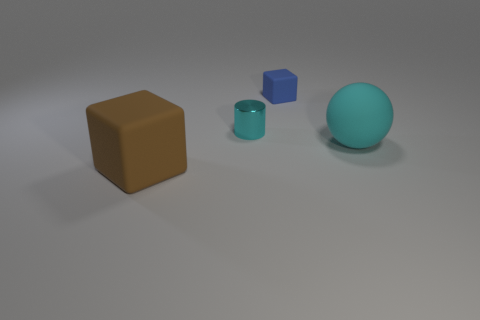Add 4 large brown rubber balls. How many objects exist? 8 Subtract all cylinders. How many objects are left? 3 Subtract 1 cylinders. How many cylinders are left? 0 Subtract all tiny matte things. Subtract all cubes. How many objects are left? 1 Add 2 tiny blue objects. How many tiny blue objects are left? 3 Add 4 blue blocks. How many blue blocks exist? 5 Subtract 0 brown spheres. How many objects are left? 4 Subtract all cyan blocks. Subtract all brown cylinders. How many blocks are left? 2 